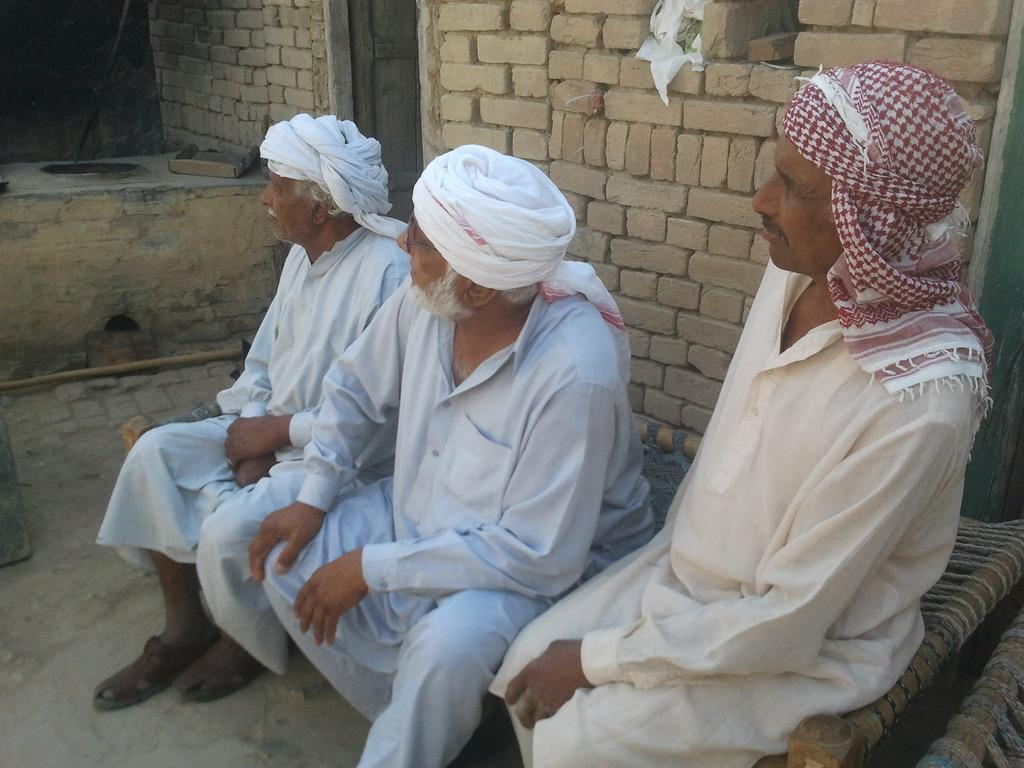How many people are sitting on the cot in the image? There are three persons sitting on a cot in the image. What can be observed about the attire of the persons in the image? The persons in the image are wearing turbans. What is visible in the background of the image? There is a wall in the background of the image. How many cushions are visible on the cot in the image? There is no mention of cushions in the image; only the three persons sitting on the cot are visible. 